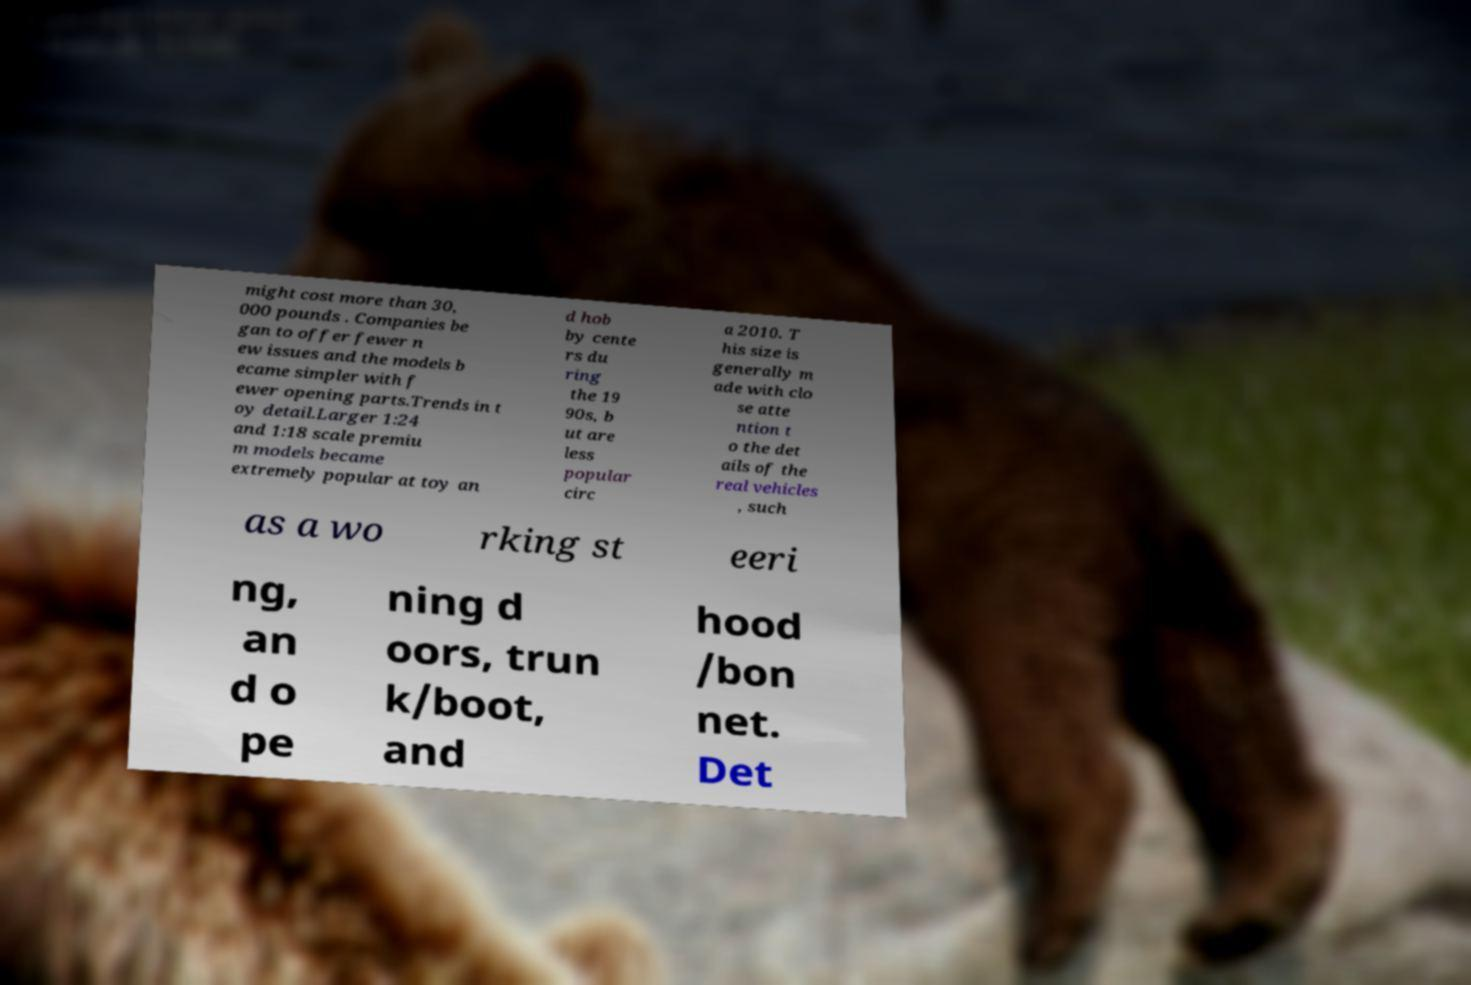Can you accurately transcribe the text from the provided image for me? might cost more than 30, 000 pounds . Companies be gan to offer fewer n ew issues and the models b ecame simpler with f ewer opening parts.Trends in t oy detail.Larger 1:24 and 1:18 scale premiu m models became extremely popular at toy an d hob by cente rs du ring the 19 90s, b ut are less popular circ a 2010. T his size is generally m ade with clo se atte ntion t o the det ails of the real vehicles , such as a wo rking st eeri ng, an d o pe ning d oors, trun k/boot, and hood /bon net. Det 